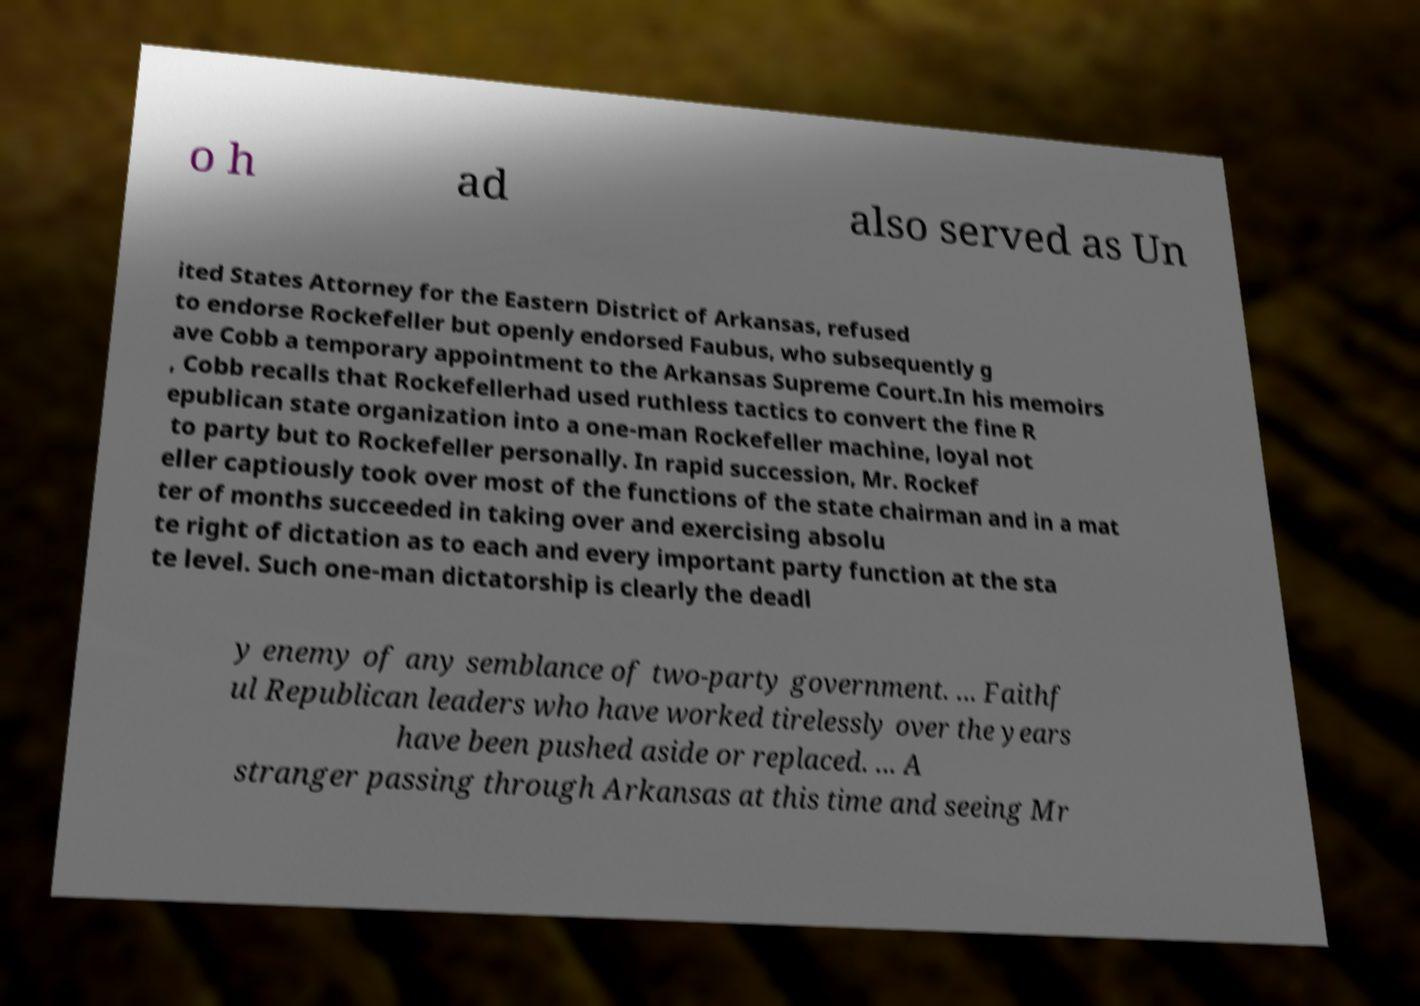For documentation purposes, I need the text within this image transcribed. Could you provide that? o h ad also served as Un ited States Attorney for the Eastern District of Arkansas, refused to endorse Rockefeller but openly endorsed Faubus, who subsequently g ave Cobb a temporary appointment to the Arkansas Supreme Court.In his memoirs , Cobb recalls that Rockefellerhad used ruthless tactics to convert the fine R epublican state organization into a one-man Rockefeller machine, loyal not to party but to Rockefeller personally. In rapid succession, Mr. Rockef eller captiously took over most of the functions of the state chairman and in a mat ter of months succeeded in taking over and exercising absolu te right of dictation as to each and every important party function at the sta te level. Such one-man dictatorship is clearly the deadl y enemy of any semblance of two-party government. ... Faithf ul Republican leaders who have worked tirelessly over the years have been pushed aside or replaced. ... A stranger passing through Arkansas at this time and seeing Mr 